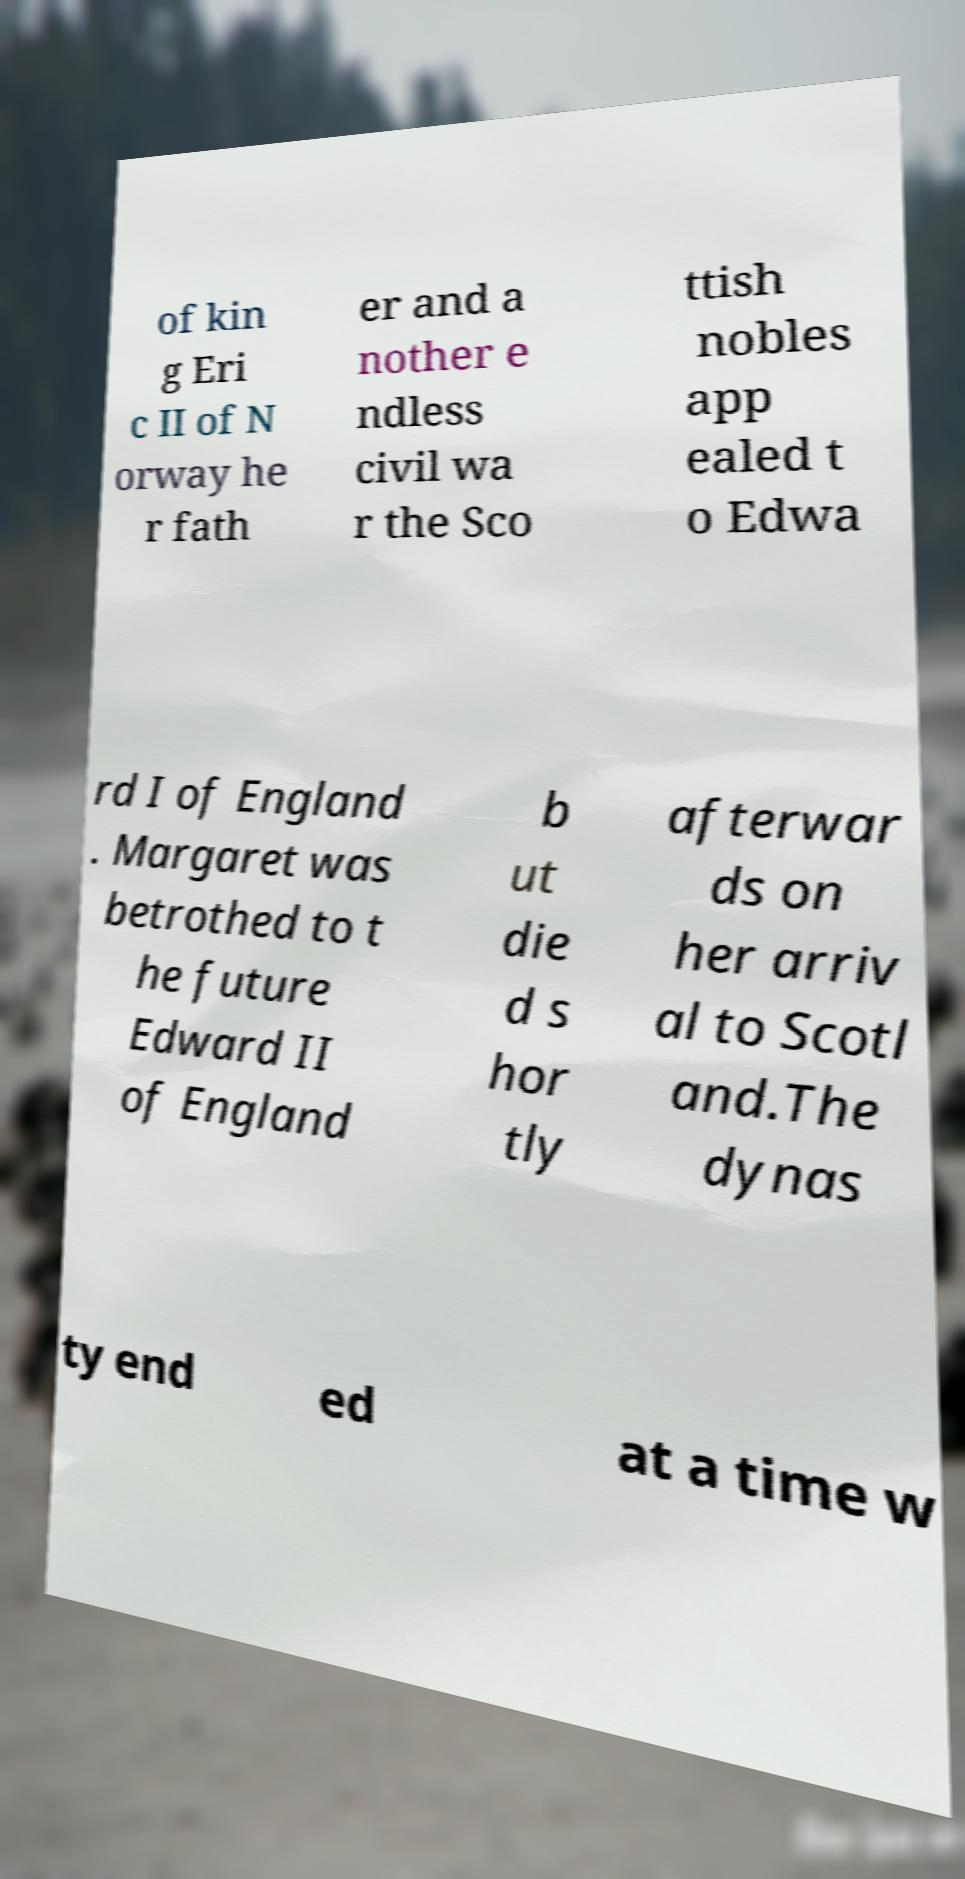Please read and relay the text visible in this image. What does it say? of kin g Eri c II of N orway he r fath er and a nother e ndless civil wa r the Sco ttish nobles app ealed t o Edwa rd I of England . Margaret was betrothed to t he future Edward II of England b ut die d s hor tly afterwar ds on her arriv al to Scotl and.The dynas ty end ed at a time w 